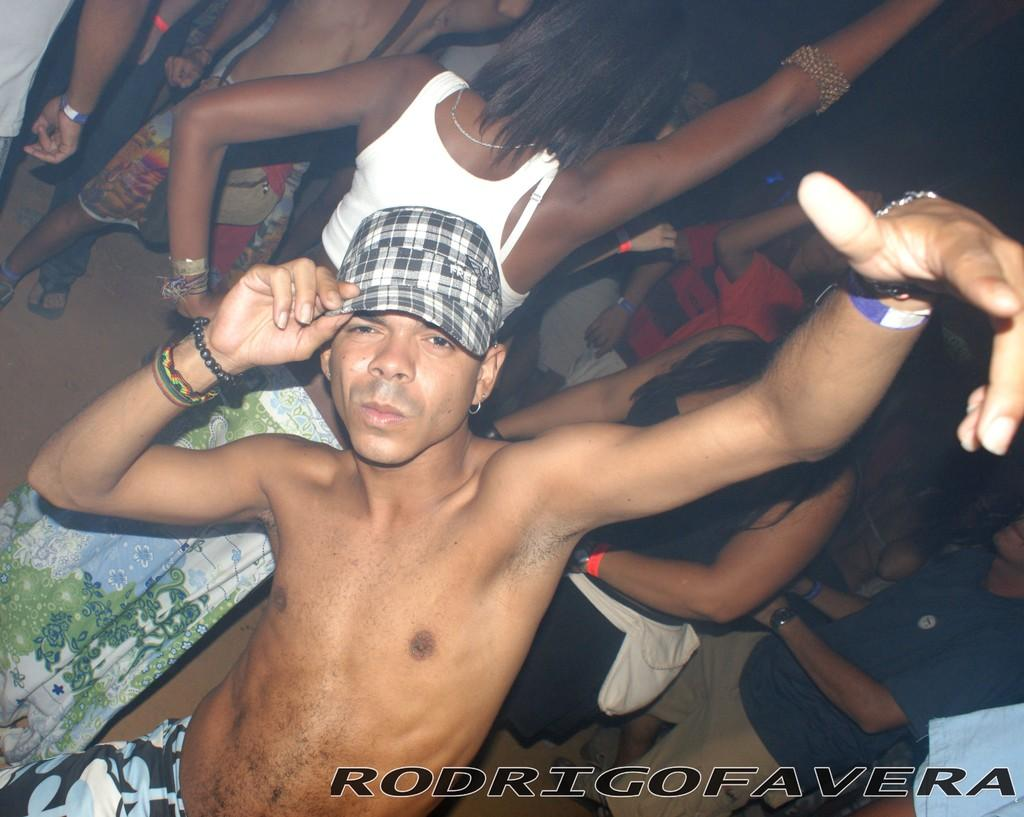What is the main subject of the image? The main subject of the image is people, specifically a man standing in the center. Can you describe the man's appearance? The man is wearing a cap. Is there any text present in the image? Yes, there is text at the bottom of the image. What type of jeans is the man wearing in the image? There is no information about the man's jeans in the image, so we cannot determine what type he is wearing. 